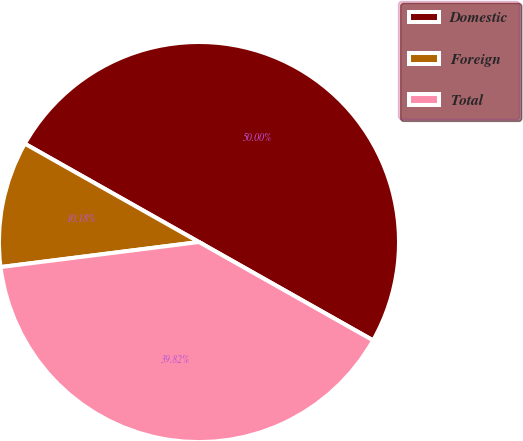Convert chart to OTSL. <chart><loc_0><loc_0><loc_500><loc_500><pie_chart><fcel>Domestic<fcel>Foreign<fcel>Total<nl><fcel>50.0%<fcel>10.18%<fcel>39.82%<nl></chart> 